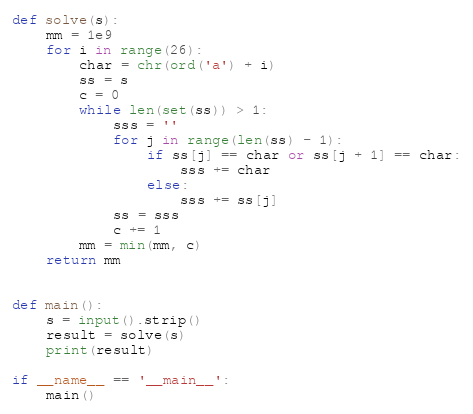Convert code to text. <code><loc_0><loc_0><loc_500><loc_500><_Python_>def solve(s):
    mm = 1e9
    for i in range(26):
        char = chr(ord('a') + i)
        ss = s
        c = 0
        while len(set(ss)) > 1:
            sss = ''
            for j in range(len(ss) - 1):
                if ss[j] == char or ss[j + 1] == char:
                    sss += char
                else:
                    sss += ss[j]
            ss = sss
            c += 1
        mm = min(mm, c)
    return mm


def main():
    s = input().strip()
    result = solve(s)
    print(result)

if __name__ == '__main__':
    main()</code> 